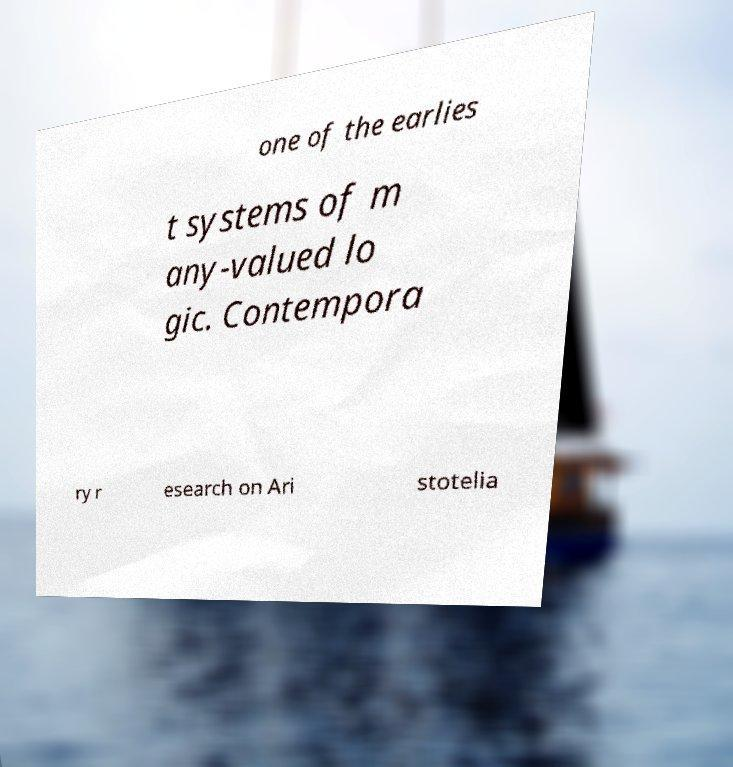Could you extract and type out the text from this image? one of the earlies t systems of m any-valued lo gic. Contempora ry r esearch on Ari stotelia 